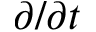Convert formula to latex. <formula><loc_0><loc_0><loc_500><loc_500>\partial / \partial t</formula> 